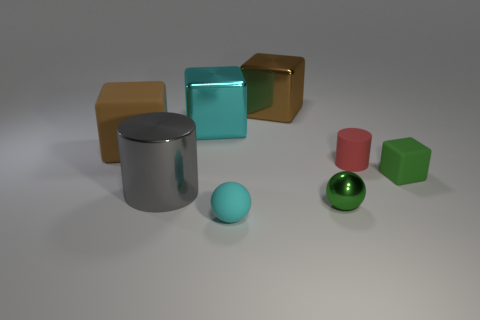Add 1 large purple rubber balls. How many objects exist? 9 Subtract all cylinders. How many objects are left? 6 Subtract all red cylinders. Subtract all matte cylinders. How many objects are left? 6 Add 3 green objects. How many green objects are left? 5 Add 7 yellow spheres. How many yellow spheres exist? 7 Subtract 0 blue spheres. How many objects are left? 8 